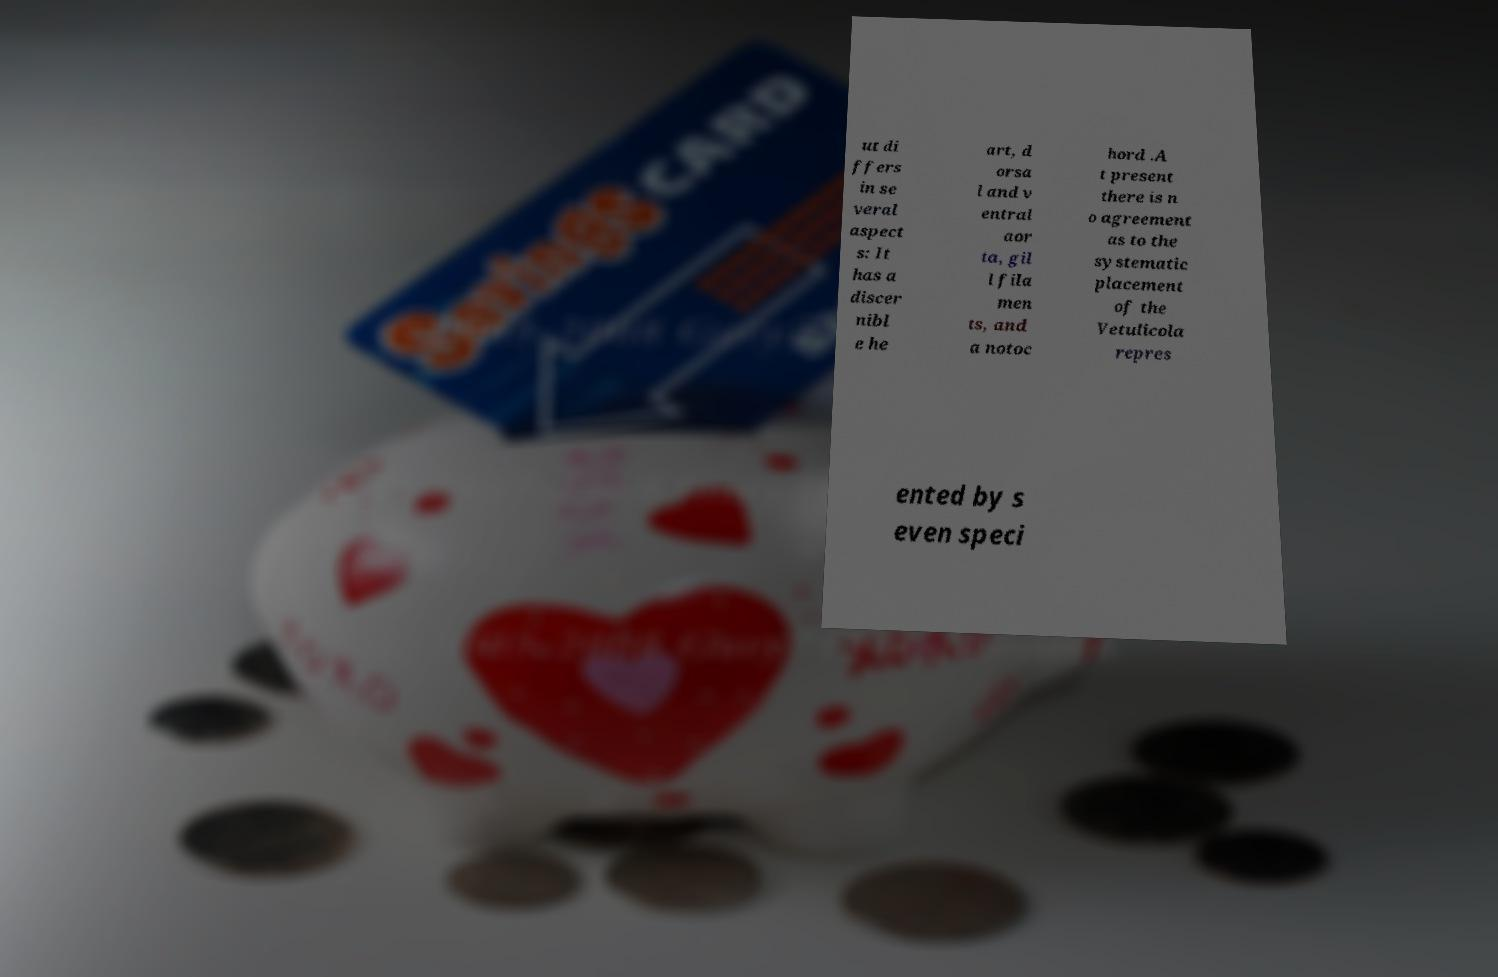Could you extract and type out the text from this image? ut di ffers in se veral aspect s: It has a discer nibl e he art, d orsa l and v entral aor ta, gil l fila men ts, and a notoc hord .A t present there is n o agreement as to the systematic placement of the Vetulicola repres ented by s even speci 